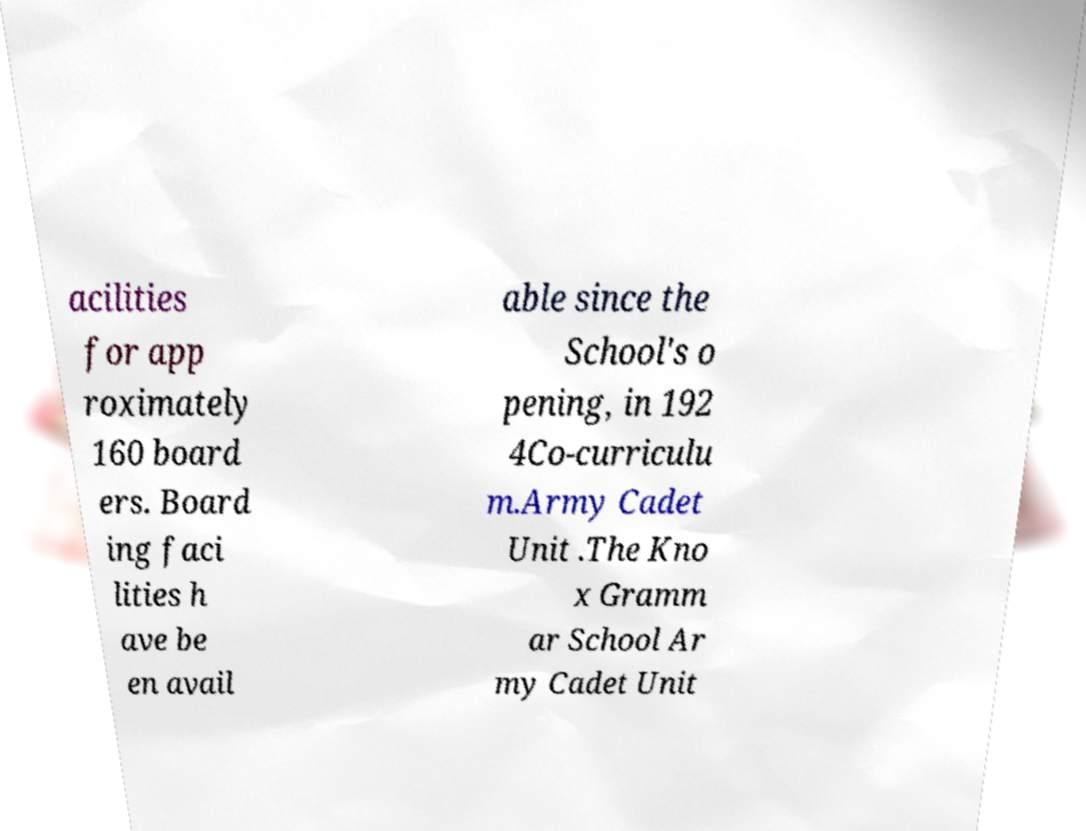For documentation purposes, I need the text within this image transcribed. Could you provide that? acilities for app roximately 160 board ers. Board ing faci lities h ave be en avail able since the School's o pening, in 192 4Co-curriculu m.Army Cadet Unit .The Kno x Gramm ar School Ar my Cadet Unit 